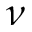<formula> <loc_0><loc_0><loc_500><loc_500>\nu</formula> 